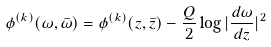Convert formula to latex. <formula><loc_0><loc_0><loc_500><loc_500>\phi ^ { ( k ) } ( \omega , \bar { \omega } ) = \phi ^ { ( k ) } ( z , \bar { z } ) - \frac { Q } { 2 } \log | \frac { d \omega } { d z } | ^ { 2 }</formula> 